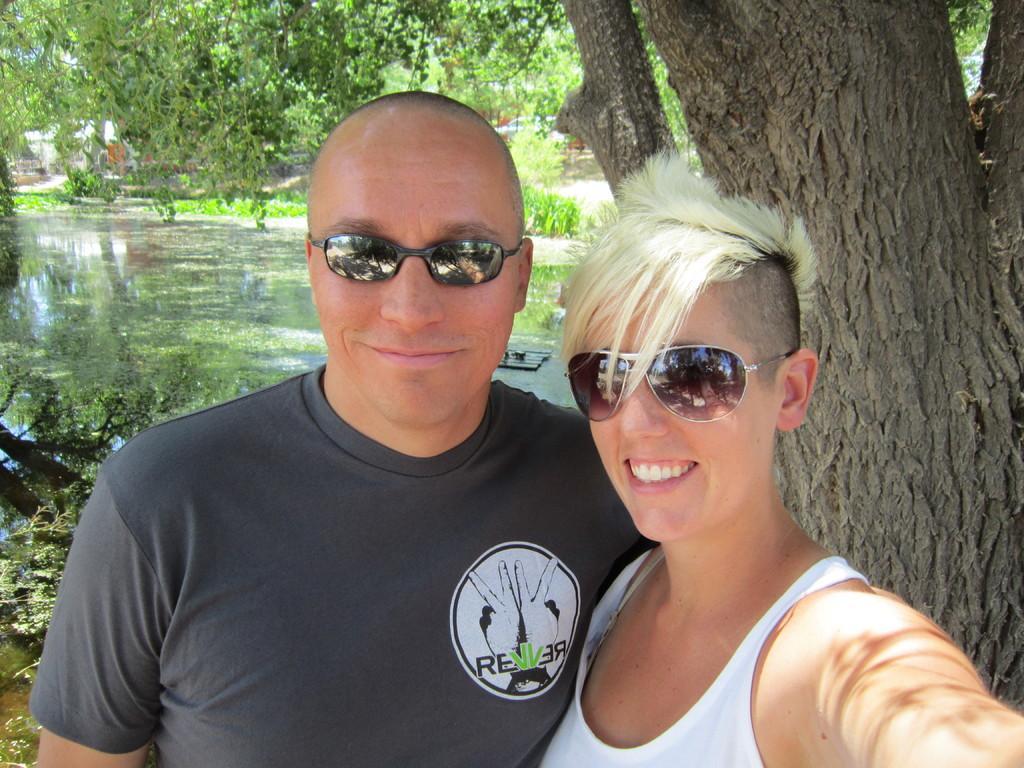In one or two sentences, can you explain what this image depicts? This picture is clicked outside. In the foreground we can see the two persons wearing t-shirts, goggles, smiling and standing. In the background we can see a water body and we can see the trees, plants and some other items. 